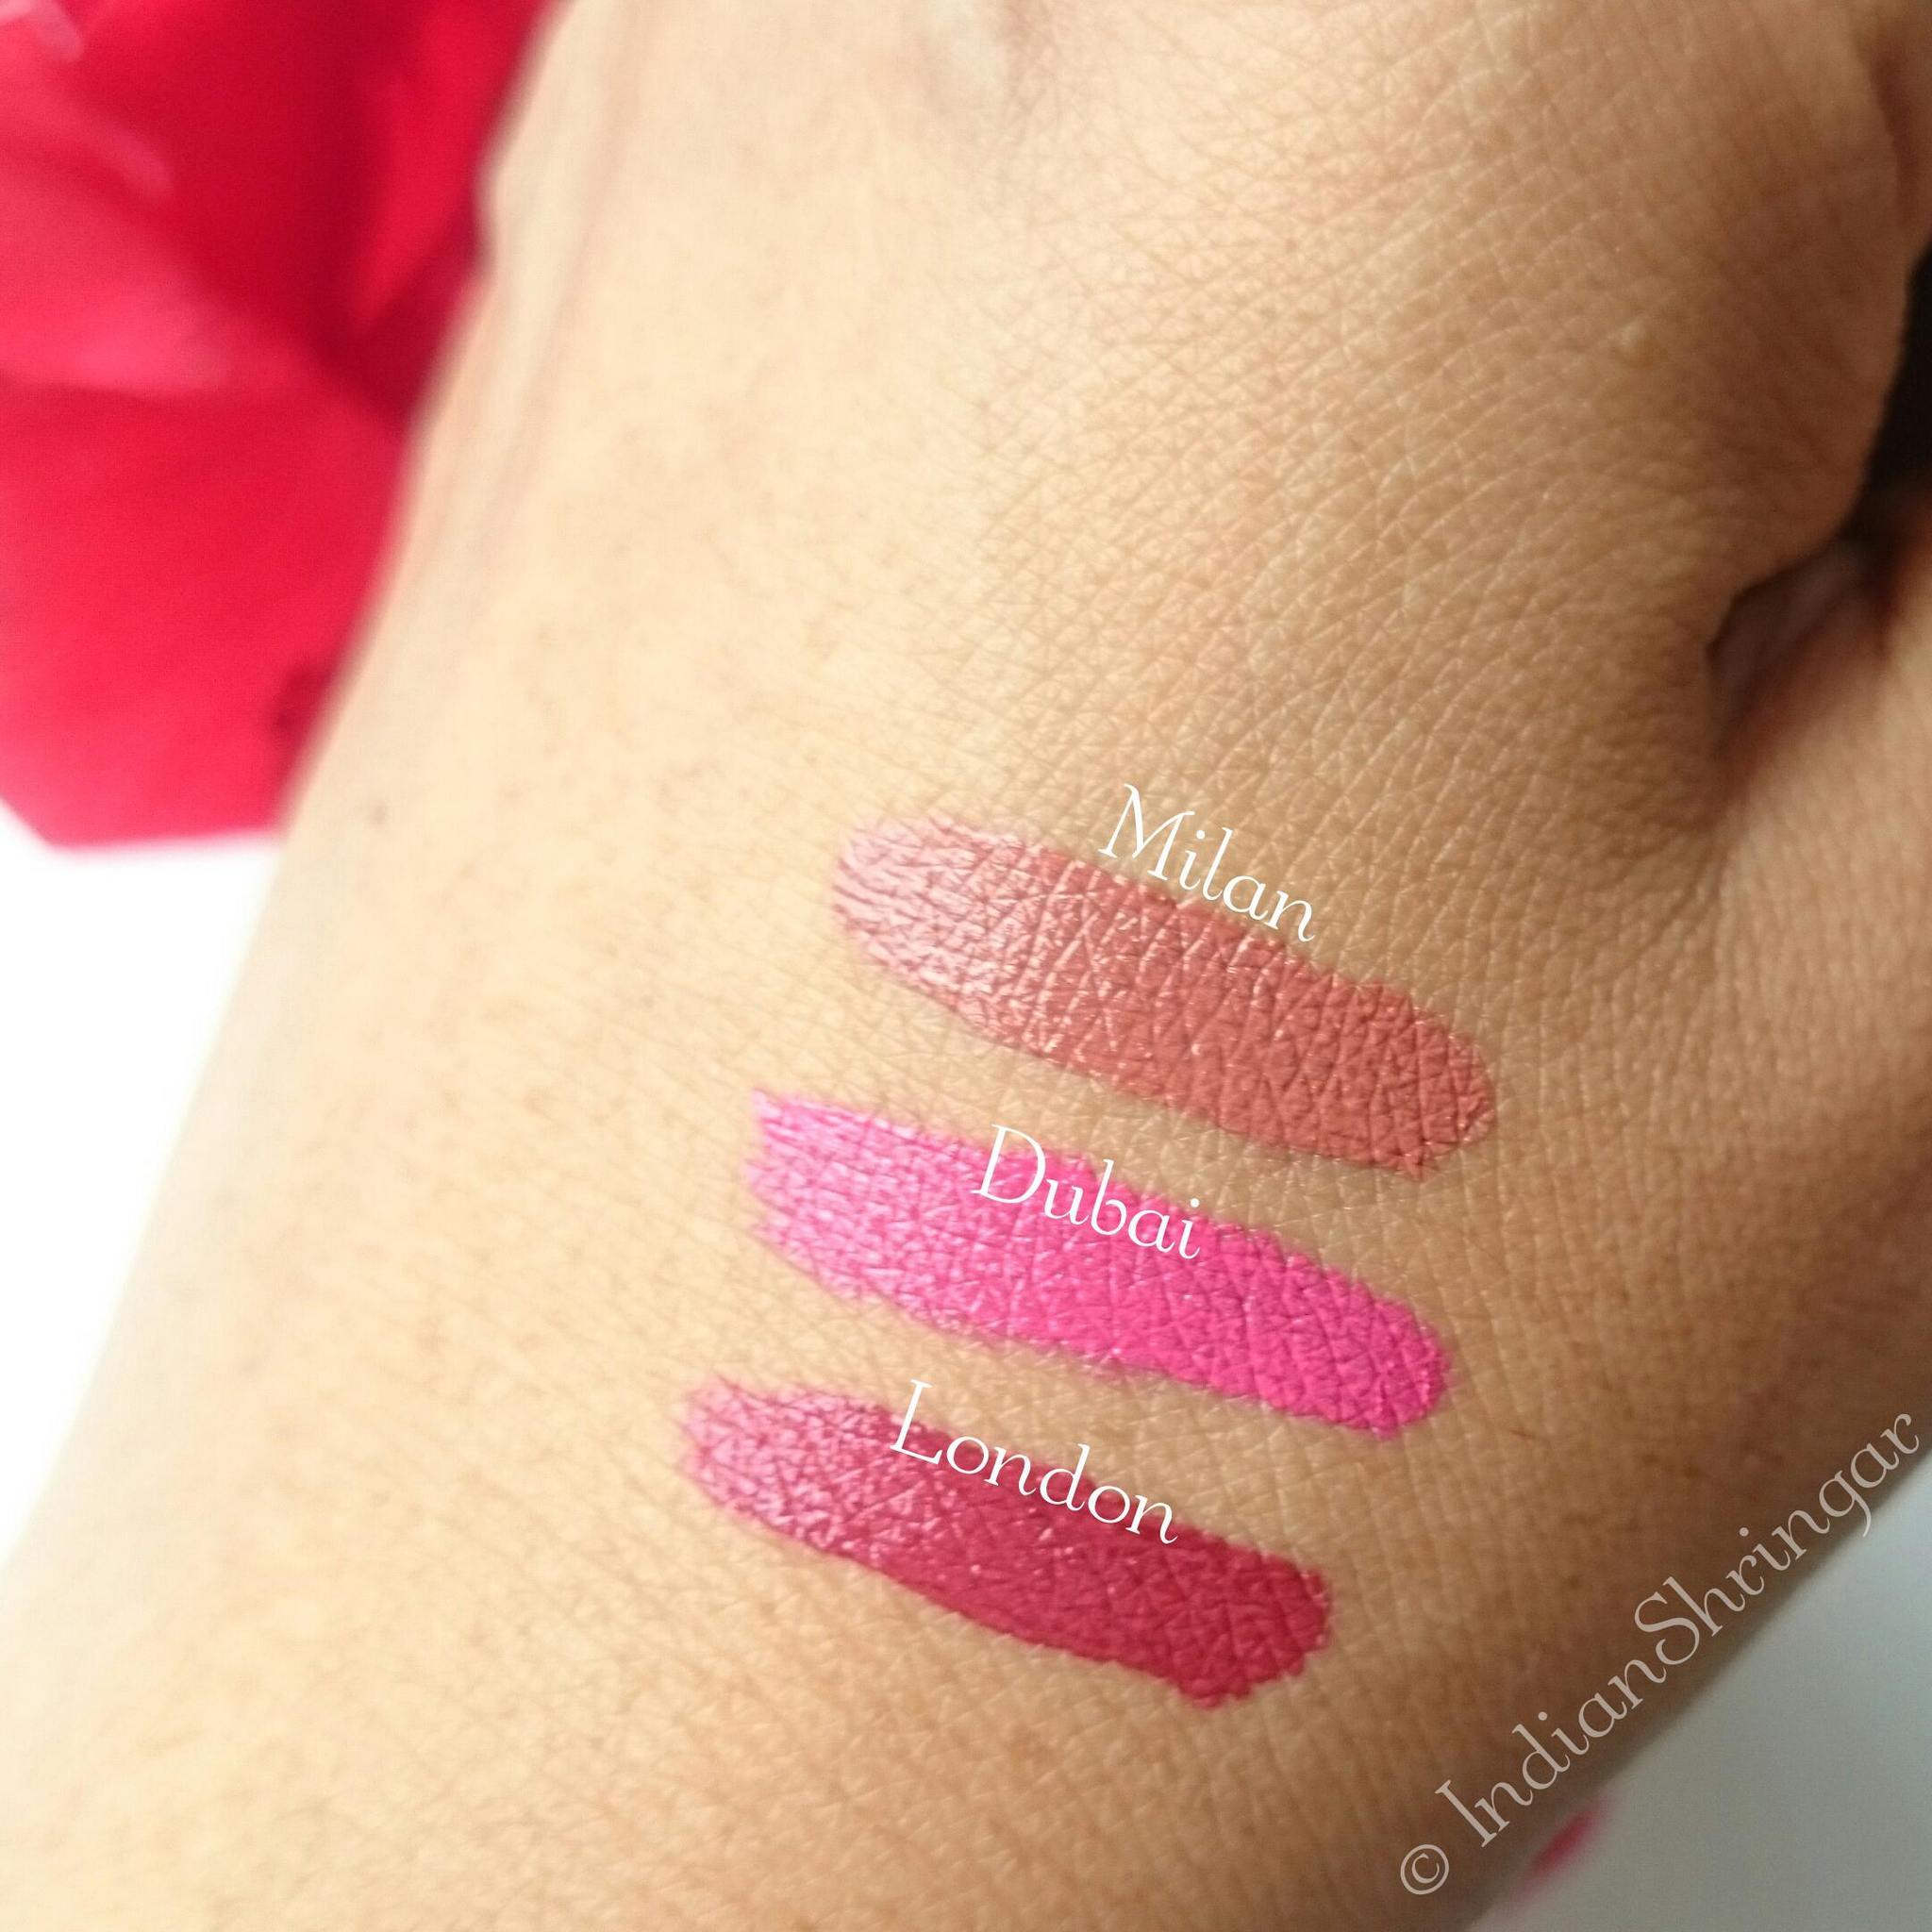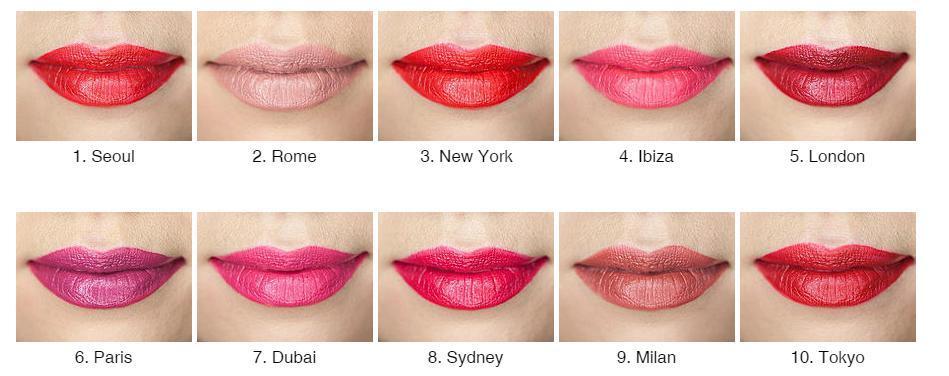The first image is the image on the left, the second image is the image on the right. Assess this claim about the two images: "A woman's teeth are visible in at least one of the images.". Correct or not? Answer yes or no. No. The first image is the image on the left, the second image is the image on the right. Evaluate the accuracy of this statement regarding the images: "The woman's eyes can be seen in one of the images". Is it true? Answer yes or no. No. 